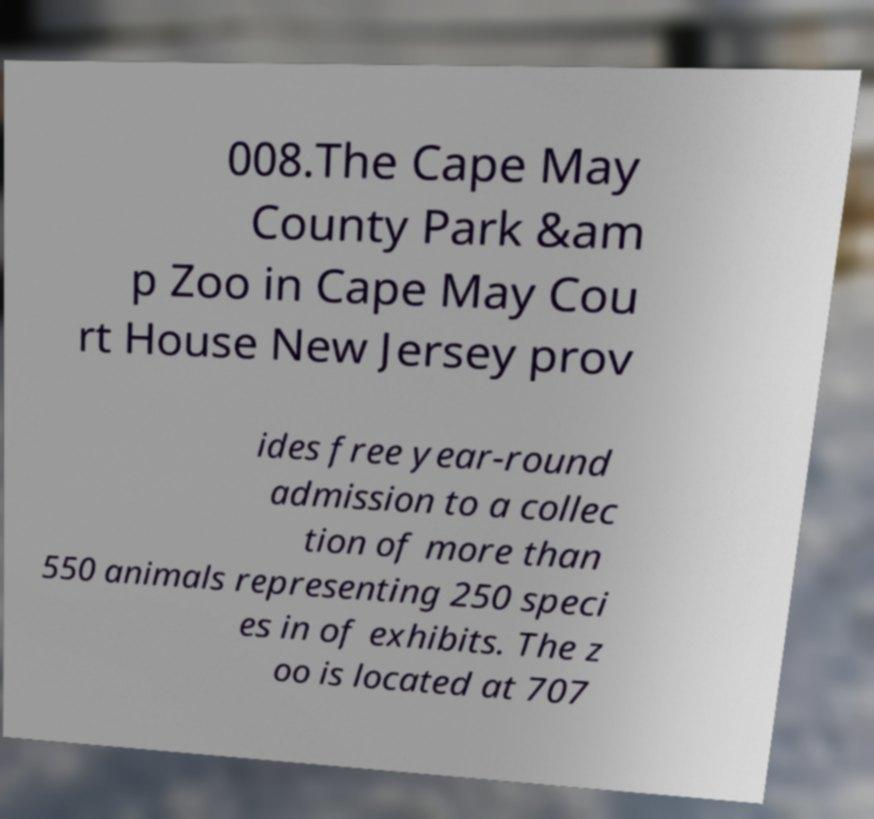Please read and relay the text visible in this image. What does it say? 008.The Cape May County Park &am p Zoo in Cape May Cou rt House New Jersey prov ides free year-round admission to a collec tion of more than 550 animals representing 250 speci es in of exhibits. The z oo is located at 707 